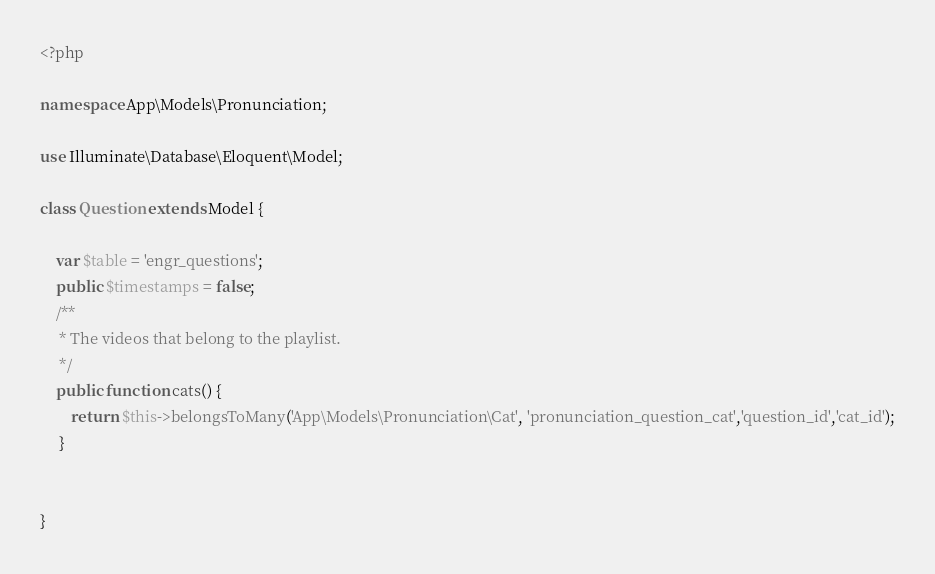Convert code to text. <code><loc_0><loc_0><loc_500><loc_500><_PHP_><?php

namespace App\Models\Pronunciation;

use Illuminate\Database\Eloquent\Model;

class Question extends Model {

    var $table = 'engr_questions';
    public $timestamps = false;
    /**
     * The videos that belong to the playlist.
     */
    public function cats() {
        return $this->belongsToMany('App\Models\Pronunciation\Cat', 'pronunciation_question_cat','question_id','cat_id');
     }

    
}
</code> 